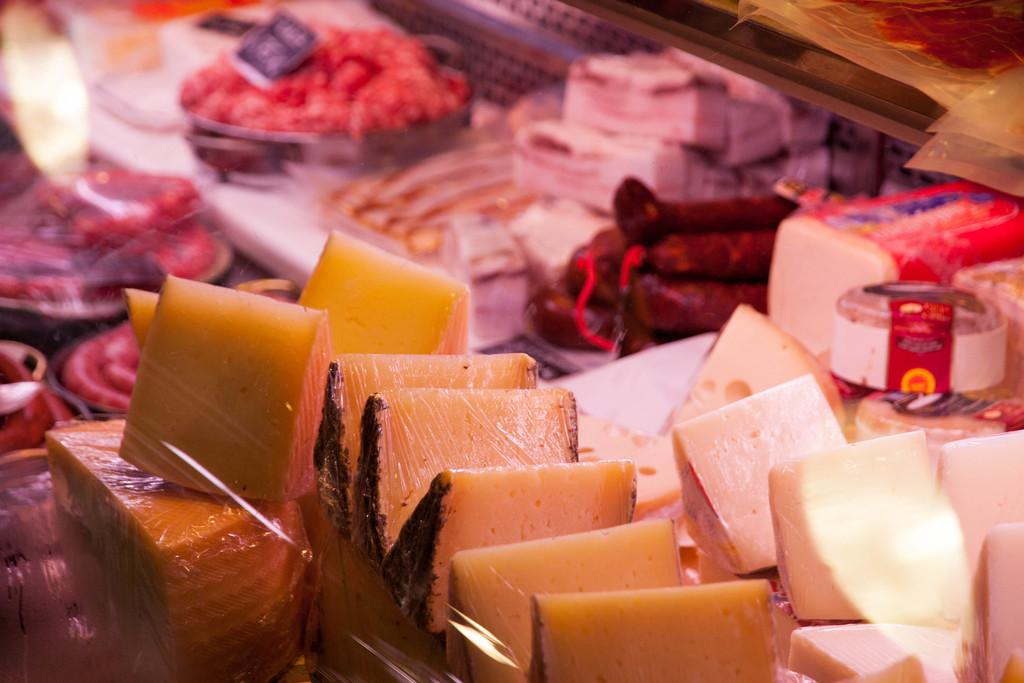What types of items can be seen in the image? There are food items in the image. Can you describe the food items in more detail? Unfortunately, the facts provided do not give specific details about the food items. Are there any other objects or elements in the image besides the food items? The facts provided do not mention any other objects or elements in the image. What type of apparel is being worn by the food items in the image? There are no people or living beings in the image, so there is no apparel associated with the food items. What is the aftermath of the food items in the image? The facts provided do not give any information about the aftermath or consequences of the food items in the image. 